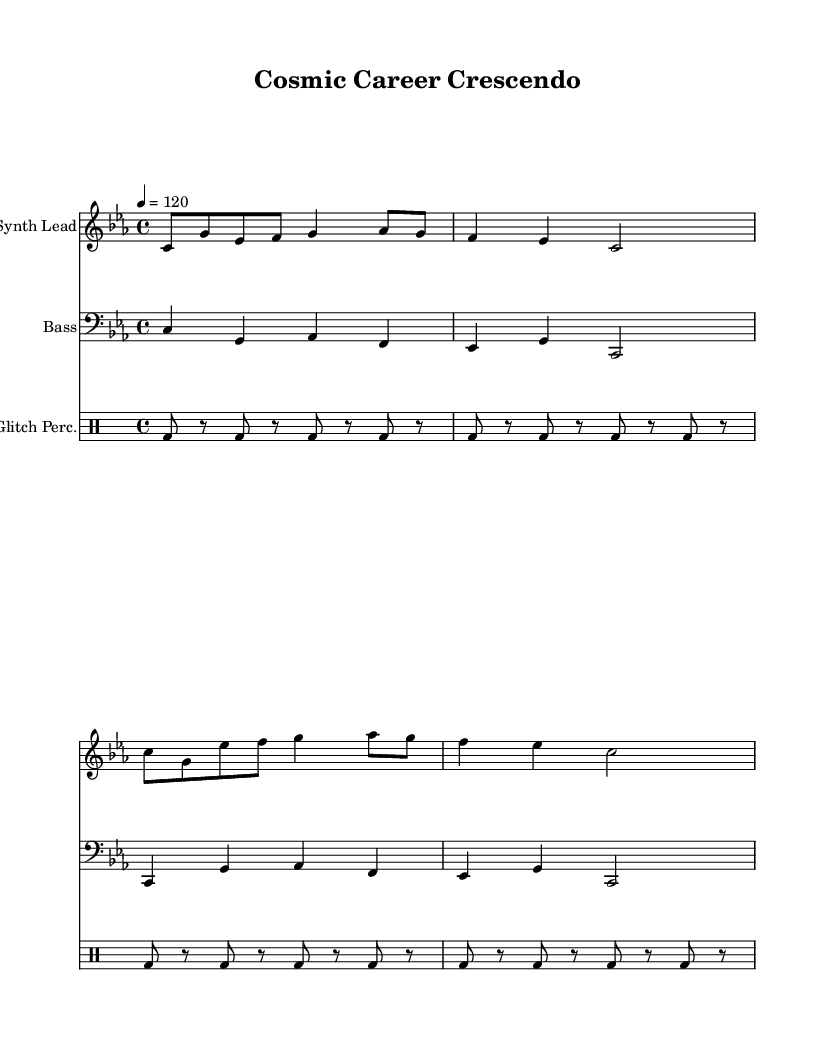What is the key signature of this music? The key signature is indicated at the beginning of the piece. In this case, it shows three flats, which corresponds to C minor.
Answer: C minor What is the time signature of this music? The time signature is found in the beginning section of the music, specifically indicated as 4/4, meaning there are four beats in a measure and the quarter note gets one beat.
Answer: 4/4 What is the tempo marking of this music? The tempo marking, located at the beginning of the score, indicates the speed of the piece. It states "4 = 120," which means there are 120 beats per minute.
Answer: 120 How many measures are in the synth lead section? To determine the number of measures, we count the distinct bars in the synth lead part, which contains 4 measures.
Answer: 4 What type of percussion is used in this composition? The score indicates "Glitch Perc." which suggests that it is using glitch-style percussion sounds. This is derived from the labeled drum staff in the music sheet.
Answer: Glitch-style What is the lyrical theme of the piece? The lyrics, which provide a narrative to the music, focus on celestial guidance and aligning career goals with zodiac wisdom, as specifically laid out in the text.
Answer: Celestial guidance How does the bass part contribute to the overall sound? The bass line provides harmonic support and rhythmic foundation, reflecting the chord changes and enhancing the groove of the piece as evidenced in the bass staff.
Answer: Harmonic foundation 